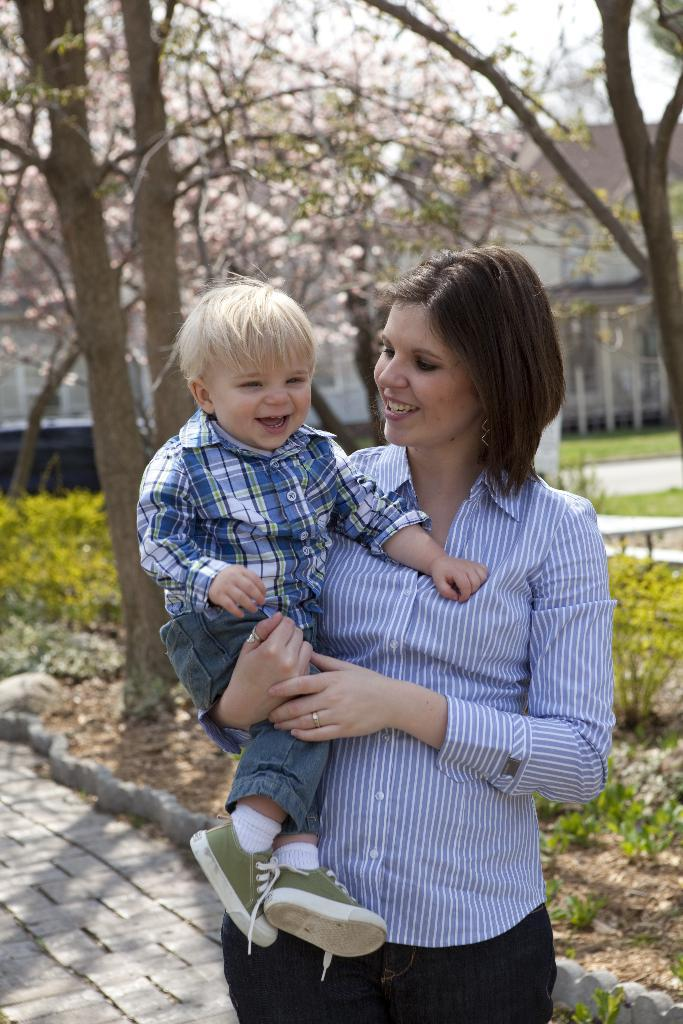Who is the main subject in the image? There is a woman in the image. What is the woman doing in the image? The woman is carrying a baby. How are the woman and the baby feeling in the image? Both the woman and the baby are smiling. What can be seen in the background of the image? There are trees, plants, a walkway, houses, and the sky visible in the background of the image. What type of feast is being prepared in the image? There is no indication of a feast being prepared in the image; it primarily focuses on the woman and the baby. What pets are visible in the image? There are no pets visible in the image. 